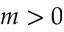<formula> <loc_0><loc_0><loc_500><loc_500>m > 0</formula> 